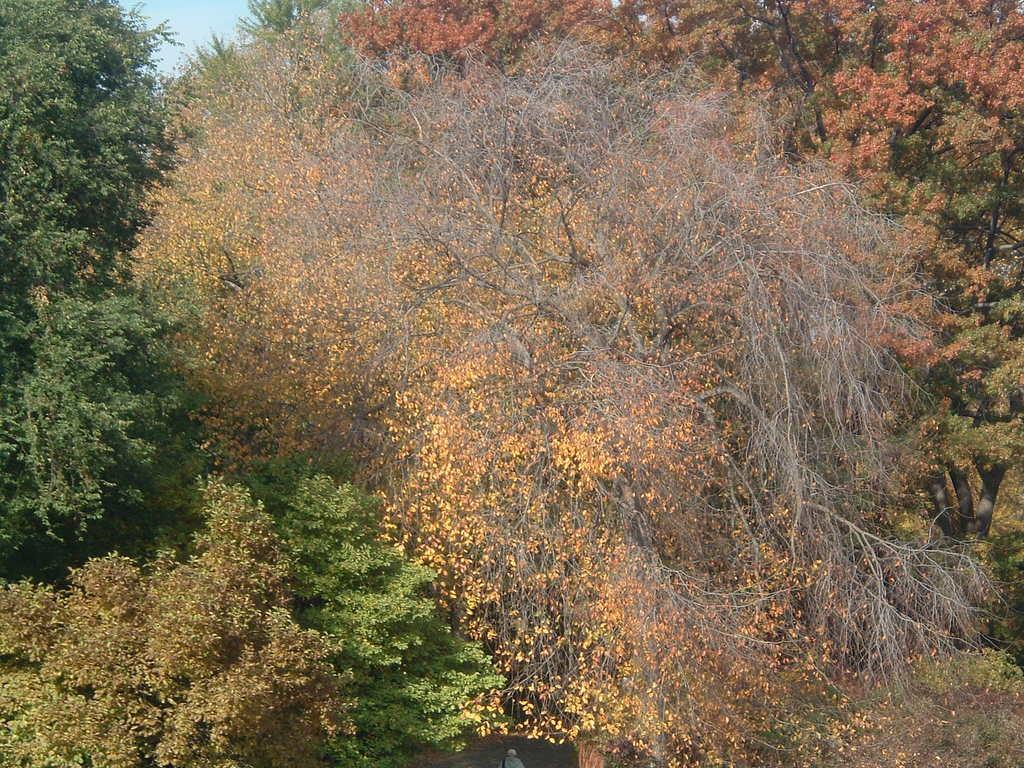What type of vegetation can be seen in the image? There are trees in the image. What colors are the trees in the image? Some trees are yellow in color, and some are green in color. Are there any trees with a different appearance in the image? Yes, there are dried trees in the image. What can be seen in the background of the image? The sky is visible in the background of the image. What type of ice can be seen melting on the trees in the image? There is no ice present in the image; the trees are either yellow, green, or dried. 